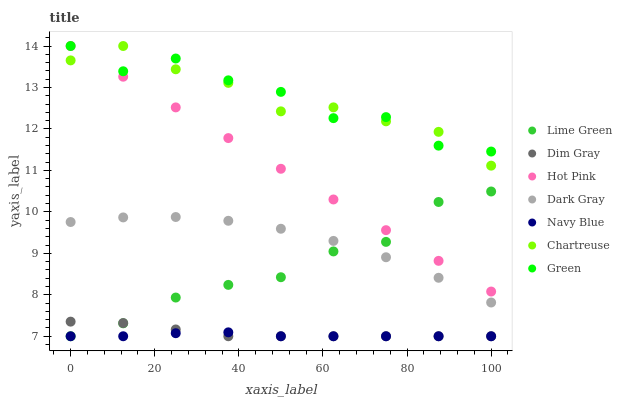Does Navy Blue have the minimum area under the curve?
Answer yes or no. Yes. Does Green have the maximum area under the curve?
Answer yes or no. Yes. Does Hot Pink have the minimum area under the curve?
Answer yes or no. No. Does Hot Pink have the maximum area under the curve?
Answer yes or no. No. Is Hot Pink the smoothest?
Answer yes or no. Yes. Is Green the roughest?
Answer yes or no. Yes. Is Navy Blue the smoothest?
Answer yes or no. No. Is Navy Blue the roughest?
Answer yes or no. No. Does Dim Gray have the lowest value?
Answer yes or no. Yes. Does Hot Pink have the lowest value?
Answer yes or no. No. Does Green have the highest value?
Answer yes or no. Yes. Does Navy Blue have the highest value?
Answer yes or no. No. Is Dim Gray less than Chartreuse?
Answer yes or no. Yes. Is Hot Pink greater than Dark Gray?
Answer yes or no. Yes. Does Chartreuse intersect Green?
Answer yes or no. Yes. Is Chartreuse less than Green?
Answer yes or no. No. Is Chartreuse greater than Green?
Answer yes or no. No. Does Dim Gray intersect Chartreuse?
Answer yes or no. No. 